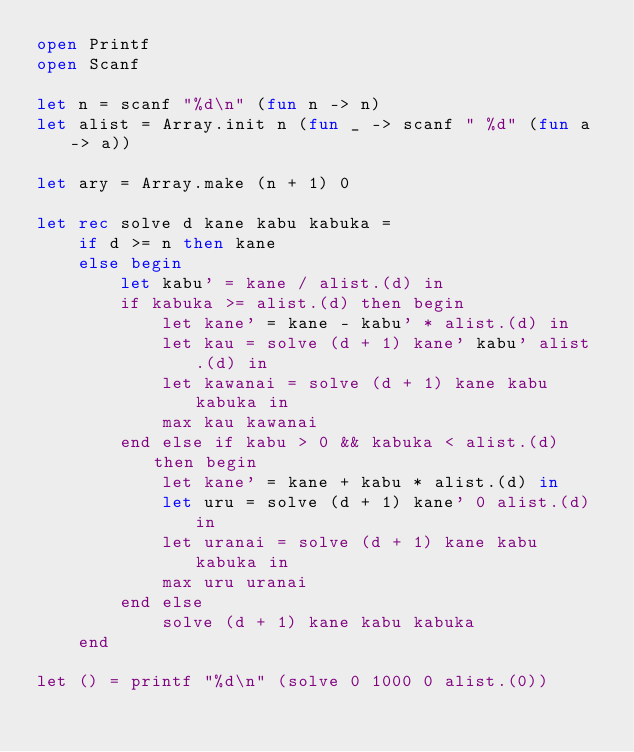Convert code to text. <code><loc_0><loc_0><loc_500><loc_500><_OCaml_>open Printf
open Scanf

let n = scanf "%d\n" (fun n -> n)
let alist = Array.init n (fun _ -> scanf " %d" (fun a -> a))

let ary = Array.make (n + 1) 0

let rec solve d kane kabu kabuka =
    if d >= n then kane
    else begin
        let kabu' = kane / alist.(d) in
        if kabuka >= alist.(d) then begin
            let kane' = kane - kabu' * alist.(d) in
            let kau = solve (d + 1) kane' kabu' alist.(d) in
            let kawanai = solve (d + 1) kane kabu kabuka in
            max kau kawanai
        end else if kabu > 0 && kabuka < alist.(d) then begin
            let kane' = kane + kabu * alist.(d) in
            let uru = solve (d + 1) kane' 0 alist.(d) in
            let uranai = solve (d + 1) kane kabu kabuka in
            max uru uranai
        end else
            solve (d + 1) kane kabu kabuka
    end

let () = printf "%d\n" (solve 0 1000 0 alist.(0))
</code> 